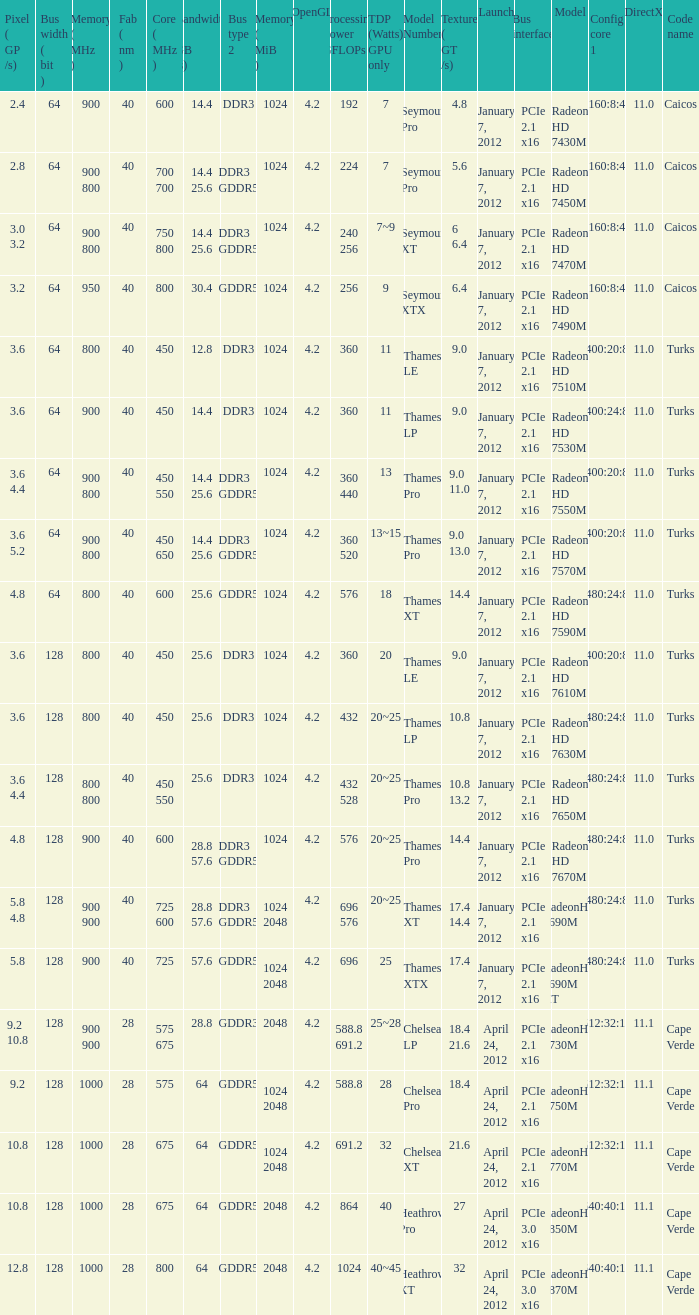What was the maximum fab (nm)? 40.0. 